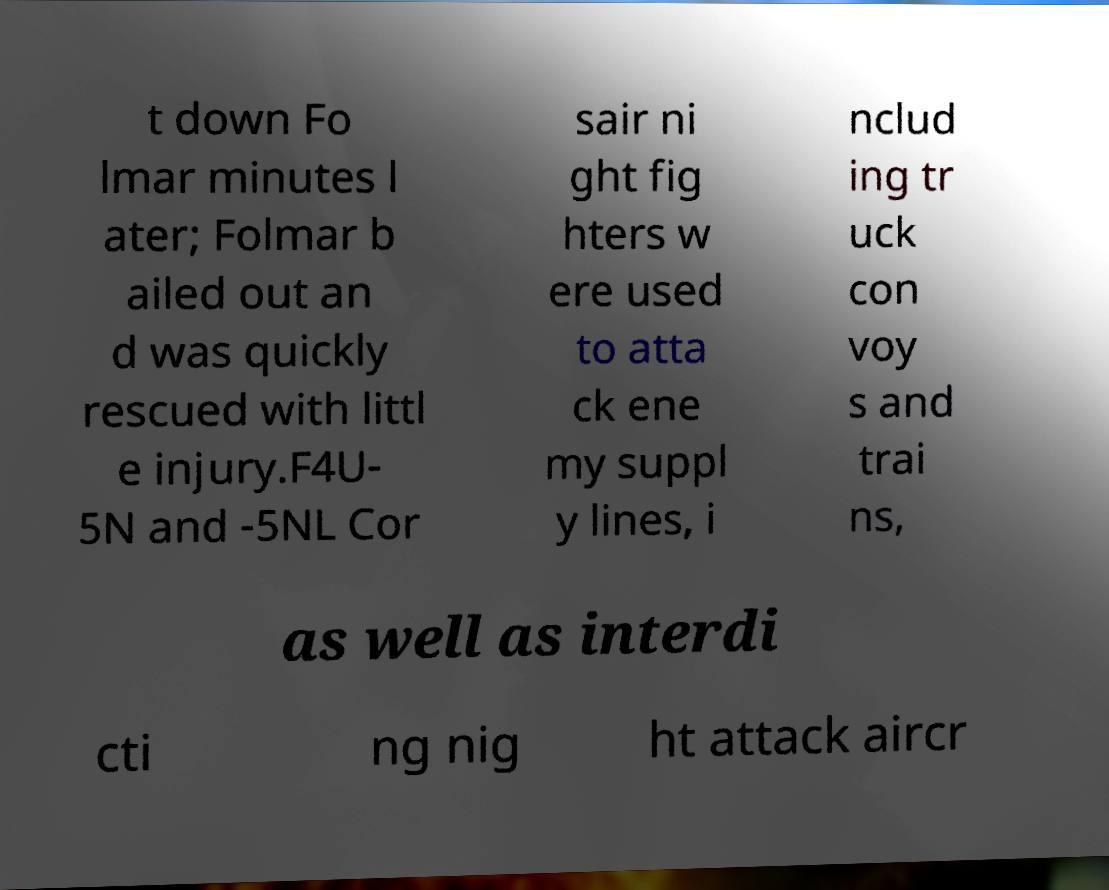Please read and relay the text visible in this image. What does it say? t down Fo lmar minutes l ater; Folmar b ailed out an d was quickly rescued with littl e injury.F4U- 5N and -5NL Cor sair ni ght fig hters w ere used to atta ck ene my suppl y lines, i nclud ing tr uck con voy s and trai ns, as well as interdi cti ng nig ht attack aircr 